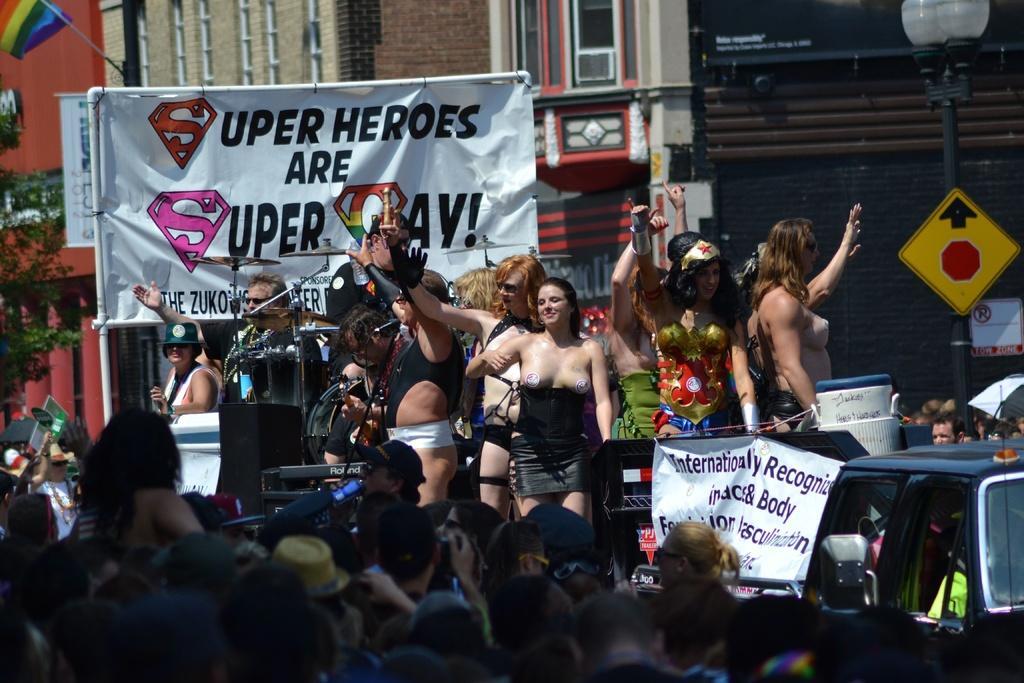How would you summarize this image in a sentence or two? In this picture I can see few people standing on the ground and few are standing on the vehicles. I can see couple banners with some text and a pole light with a sign board on the right side of the picture. I can see buildings, a flag and a tree in the background. 